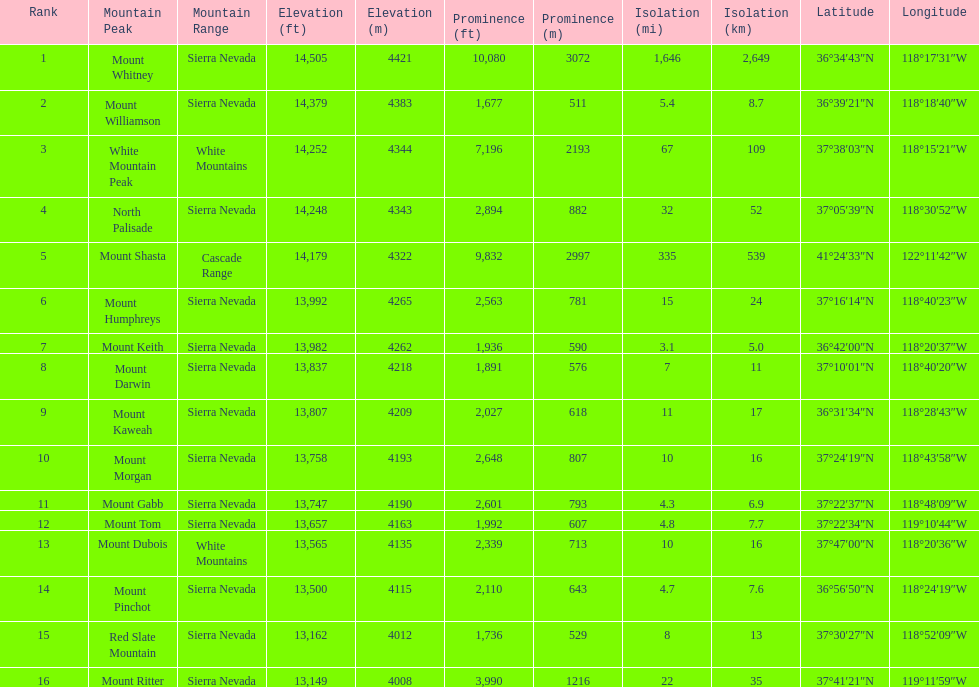What is the tallest peak in the sierra nevadas? Mount Whitney. 